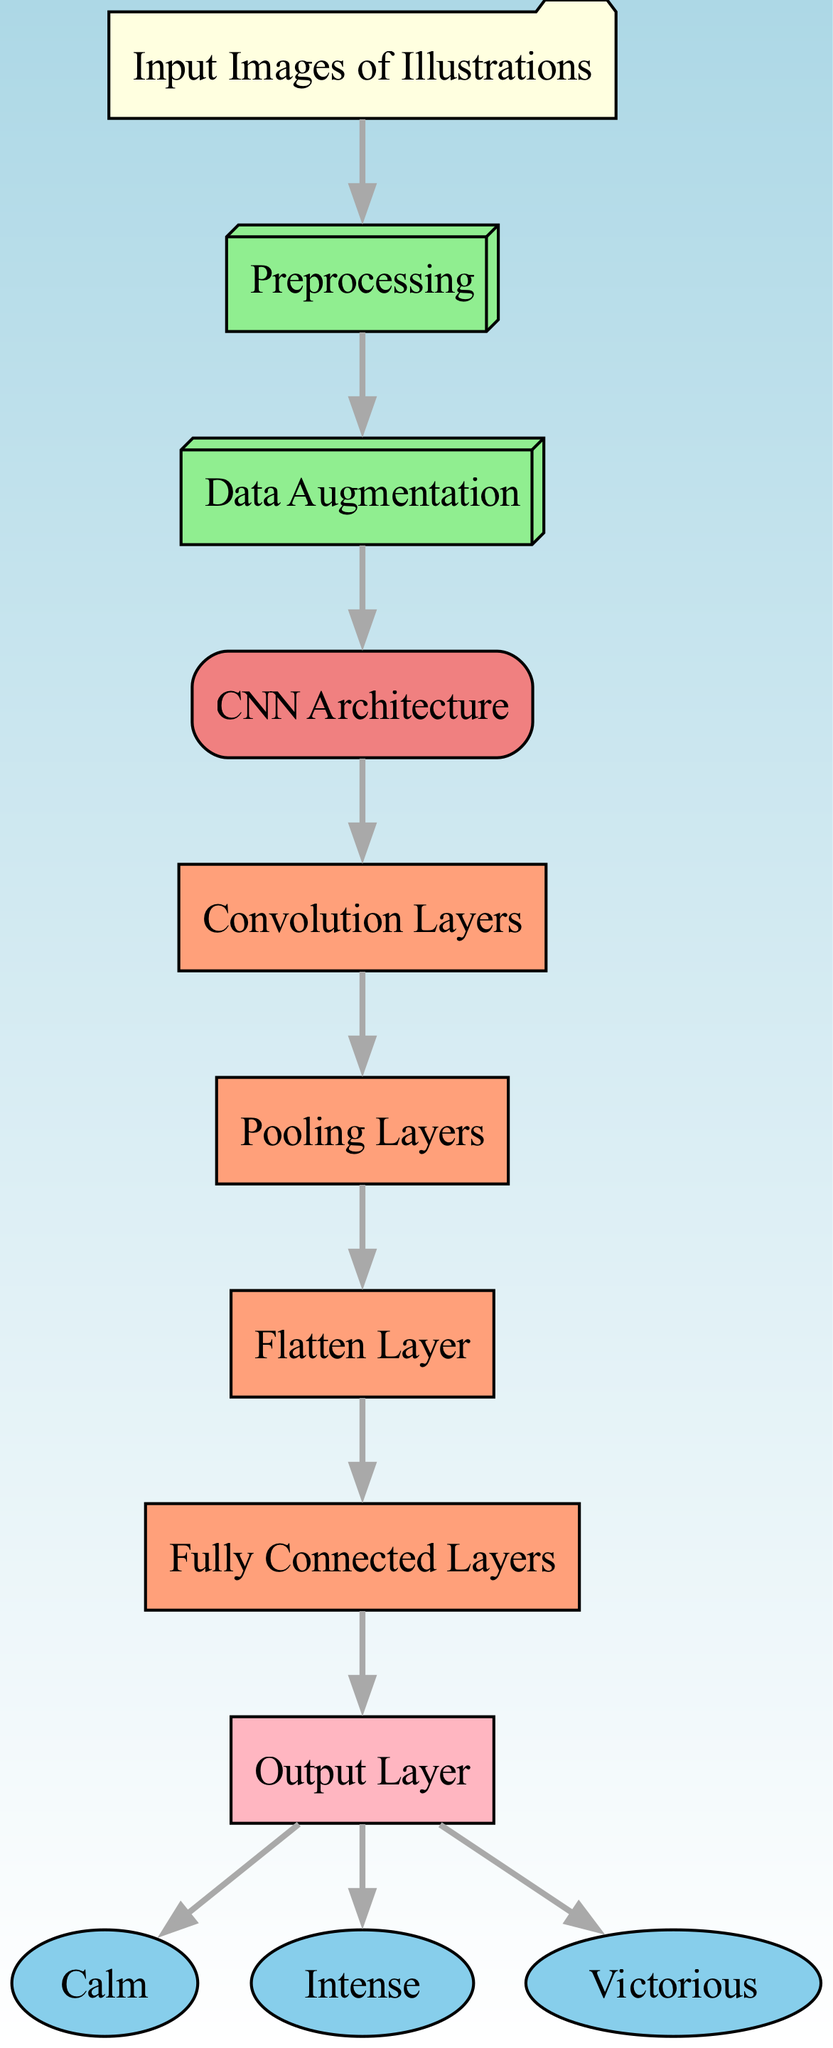What is the first node in the diagram? The first node, as indicated by its position at the top of the diagram, is "Input Images of Illustrations".
Answer: Input Images of Illustrations How many output categories does the model classify? The model has three output categories: calm, intense, and victorious, as shown in the diagram.
Answer: Three What follows the Data Augmentation node? The node that follows the "Data Augmentation" node is the "CNN Architecture" node, indicating the transition to the model structure.
Answer: CNN Architecture Which layer directly connects to the Flatten Layer? The "Pooling Layers" node is the one that directly connects to the "Flatten Layer" node, indicating a sequence in processing.
Answer: Pooling Layers What is the color of the Output Layer in the diagram? The "Output Layer" is colored light pink, distinguishing it from other layers in the diagram.
Answer: Light pink What is the relationship between the Output Layer and calm? The "Output Layer" directly connects to the "Calm" node, indicating that calm is one of the categories processed by the model.
Answer: Direct connection How many edges originate from the CNN Architecture node? Two edges originate from the "CNN Architecture" node, leading to the convolution and pooling layers respectively.
Answer: Two What type of layers are found between the Convolution Layers and Output Layer? After the "Convolution Layers," the sequence includes "Pooling Layers," "Flatten Layer," and "Fully Connected Layers," indicating a typical CNN processing flow.
Answer: Pooling, Flatten, Fully Connected Which nodes represent the emotional categories in the diagram? The emotional categories represented in the diagram are "Calm", "Intense", and "Victorious," depicted as endpoints of the classification process.
Answer: Calm, Intense, Victorious 